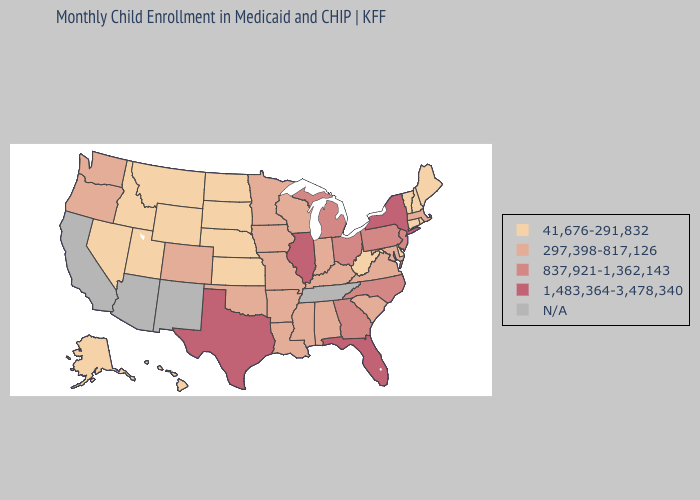Does the map have missing data?
Write a very short answer. Yes. Does Connecticut have the lowest value in the USA?
Give a very brief answer. Yes. Does Missouri have the lowest value in the USA?
Answer briefly. No. Does the first symbol in the legend represent the smallest category?
Quick response, please. Yes. What is the value of Florida?
Write a very short answer. 1,483,364-3,478,340. What is the lowest value in states that border New Jersey?
Concise answer only. 41,676-291,832. Does South Dakota have the lowest value in the MidWest?
Give a very brief answer. Yes. Does Massachusetts have the lowest value in the Northeast?
Quick response, please. No. Does Wyoming have the lowest value in the USA?
Answer briefly. Yes. Does the first symbol in the legend represent the smallest category?
Short answer required. Yes. How many symbols are there in the legend?
Keep it brief. 5. What is the value of Virginia?
Answer briefly. 297,398-817,126. Does Pennsylvania have the highest value in the USA?
Answer briefly. No. 